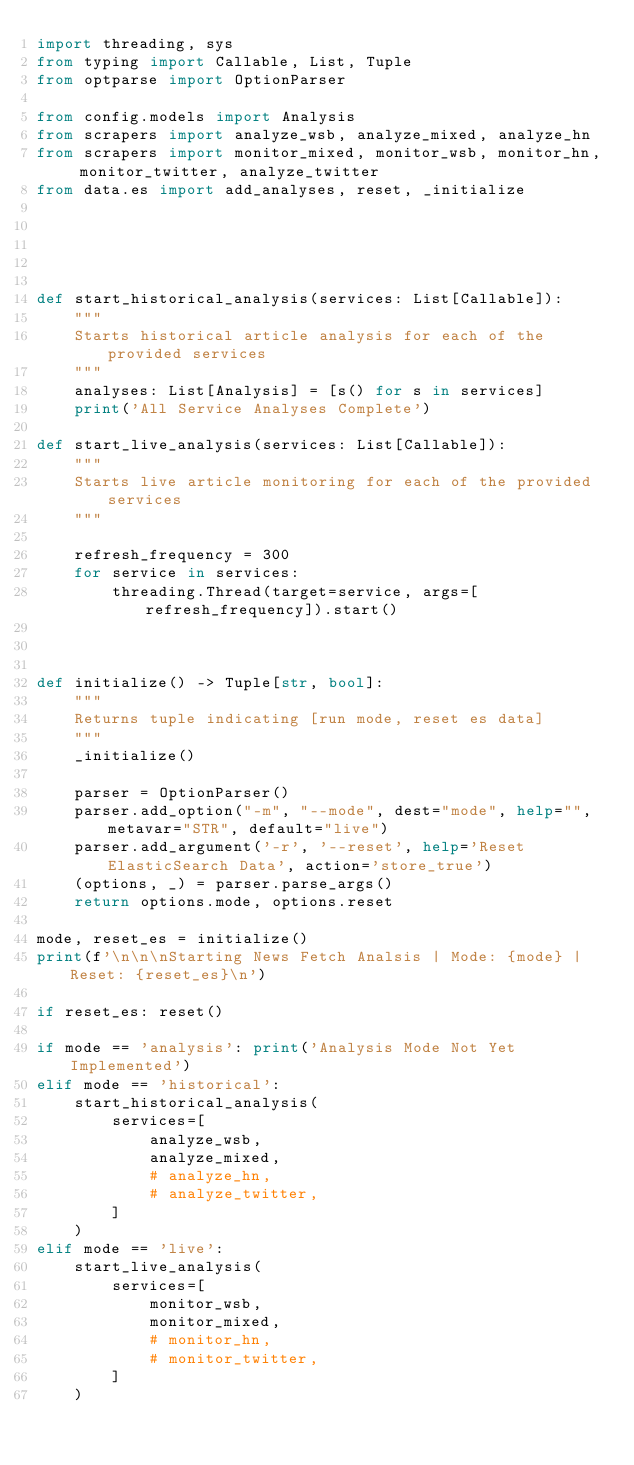Convert code to text. <code><loc_0><loc_0><loc_500><loc_500><_Python_>import threading, sys
from typing import Callable, List, Tuple
from optparse import OptionParser

from config.models import Analysis
from scrapers import analyze_wsb, analyze_mixed, analyze_hn
from scrapers import monitor_mixed, monitor_wsb, monitor_hn, monitor_twitter, analyze_twitter
from data.es import add_analyses, reset, _initialize





def start_historical_analysis(services: List[Callable]):
    """
    Starts historical article analysis for each of the provided services
    """
    analyses: List[Analysis] = [s() for s in services]
    print('All Service Analyses Complete')

def start_live_analysis(services: List[Callable]):
    """
    Starts live article monitoring for each of the provided services
    """
    
    refresh_frequency = 300
    for service in services:
        threading.Thread(target=service, args=[refresh_frequency]).start()



def initialize() -> Tuple[str, bool]:
    """
    Returns tuple indicating [run mode, reset es data]
    """
    _initialize()

    parser = OptionParser()
    parser.add_option("-m", "--mode", dest="mode", help="", metavar="STR", default="live")
    parser.add_argument('-r', '--reset', help='Reset ElasticSearch Data', action='store_true')
    (options, _) = parser.parse_args()
    return options.mode, options.reset

mode, reset_es = initialize()
print(f'\n\n\nStarting News Fetch Analsis | Mode: {mode} | Reset: {reset_es}\n')

if reset_es: reset()

if mode == 'analysis': print('Analysis Mode Not Yet Implemented')
elif mode == 'historical':
    start_historical_analysis(
        services=[
            analyze_wsb,
            analyze_mixed,
            # analyze_hn,
            # analyze_twitter,
        ]
    )
elif mode == 'live':
    start_live_analysis(
        services=[
            monitor_wsb,
            monitor_mixed,
            # monitor_hn,
            # monitor_twitter,
        ]
    )
</code> 